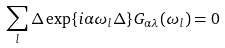<formula> <loc_0><loc_0><loc_500><loc_500>\sum _ { l } \Delta \exp \{ i \alpha \omega _ { l } \Delta \} G _ { \alpha \lambda } ( \omega _ { l } ) = 0</formula> 